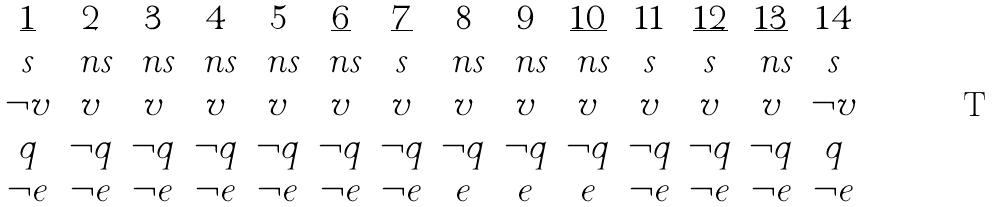Convert formula to latex. <formula><loc_0><loc_0><loc_500><loc_500>\begin{array} { c c c c c c c c c c c c c c } \underline { 1 } & 2 & 3 & 4 & 5 & \underline { 6 } & \underline { 7 } & 8 & 9 & \underline { 1 0 } & 1 1 & \underline { 1 2 } & \underline { 1 3 } & 1 4 \\ s & \ n s & \ n s & \ n s & \ n s & \ n s & s & \ n s & \ n s & \ n s & s & s & \ n s & s \\ \neg v & v & v & v & v & v & v & v & v & v & v & v & v & \neg v \\ q & \neg q & \neg q & \neg q & \neg q & \neg q & \neg q & \neg q & \neg q & \neg q & \neg q & \neg q & \neg q & q \\ \neg e & \neg e & \neg e & \neg e & \neg e & \neg e & \neg e & e & e & e & \neg e & \neg e & \neg e & \neg e \\ \end{array}</formula> 